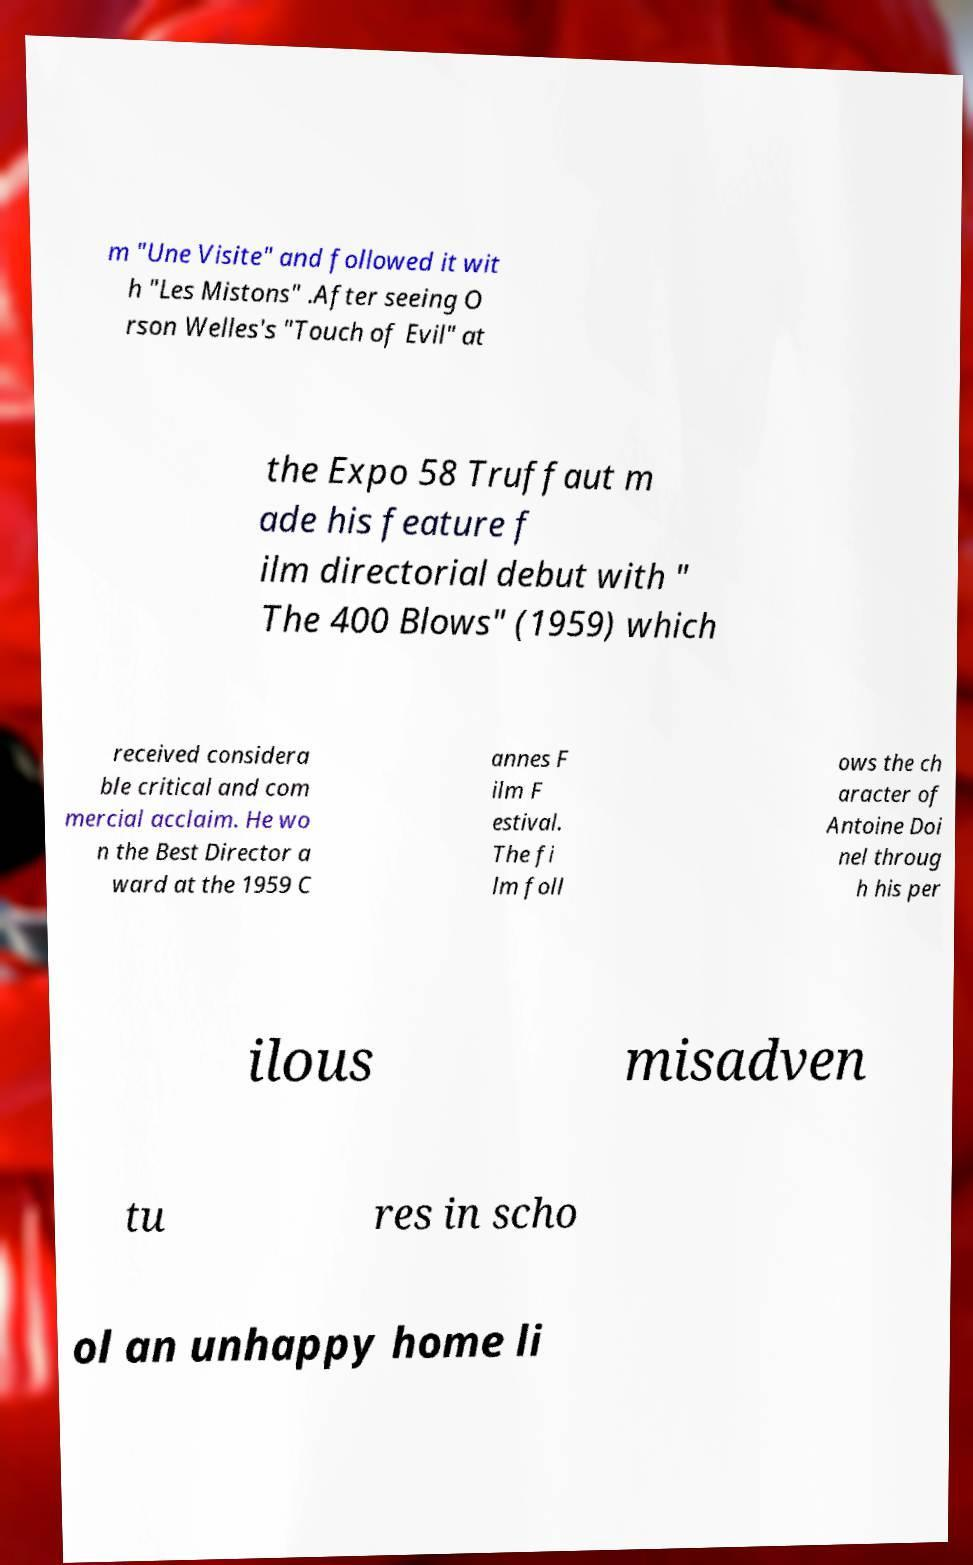Please identify and transcribe the text found in this image. m "Une Visite" and followed it wit h "Les Mistons" .After seeing O rson Welles's "Touch of Evil" at the Expo 58 Truffaut m ade his feature f ilm directorial debut with " The 400 Blows" (1959) which received considera ble critical and com mercial acclaim. He wo n the Best Director a ward at the 1959 C annes F ilm F estival. The fi lm foll ows the ch aracter of Antoine Doi nel throug h his per ilous misadven tu res in scho ol an unhappy home li 